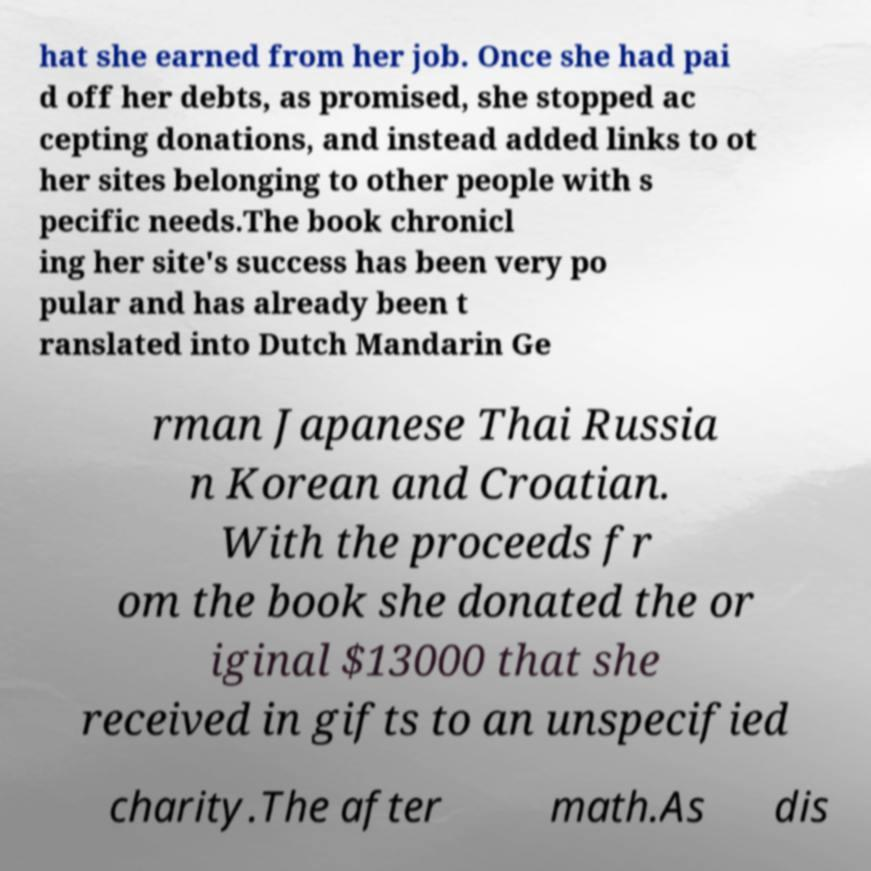Please read and relay the text visible in this image. What does it say? hat she earned from her job. Once she had pai d off her debts, as promised, she stopped ac cepting donations, and instead added links to ot her sites belonging to other people with s pecific needs.The book chronicl ing her site's success has been very po pular and has already been t ranslated into Dutch Mandarin Ge rman Japanese Thai Russia n Korean and Croatian. With the proceeds fr om the book she donated the or iginal $13000 that she received in gifts to an unspecified charity.The after math.As dis 